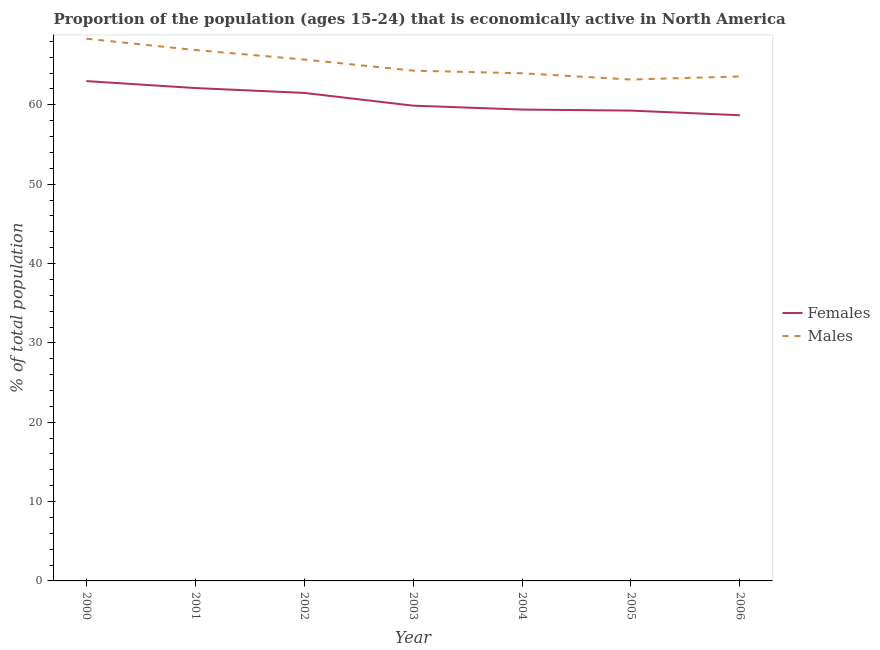How many different coloured lines are there?
Give a very brief answer. 2. What is the percentage of economically active male population in 2004?
Ensure brevity in your answer.  63.98. Across all years, what is the maximum percentage of economically active male population?
Your answer should be compact. 68.33. Across all years, what is the minimum percentage of economically active female population?
Your answer should be compact. 58.69. In which year was the percentage of economically active female population maximum?
Keep it short and to the point. 2000. In which year was the percentage of economically active female population minimum?
Make the answer very short. 2006. What is the total percentage of economically active male population in the graph?
Your answer should be compact. 455.99. What is the difference between the percentage of economically active female population in 2001 and that in 2005?
Keep it short and to the point. 2.84. What is the difference between the percentage of economically active female population in 2004 and the percentage of economically active male population in 2001?
Offer a very short reply. -7.5. What is the average percentage of economically active female population per year?
Offer a very short reply. 60.55. In the year 2005, what is the difference between the percentage of economically active male population and percentage of economically active female population?
Your answer should be compact. 3.92. What is the ratio of the percentage of economically active male population in 2001 to that in 2004?
Give a very brief answer. 1.05. What is the difference between the highest and the second highest percentage of economically active male population?
Your answer should be compact. 1.43. What is the difference between the highest and the lowest percentage of economically active female population?
Keep it short and to the point. 4.3. In how many years, is the percentage of economically active male population greater than the average percentage of economically active male population taken over all years?
Ensure brevity in your answer.  3. Is the percentage of economically active male population strictly less than the percentage of economically active female population over the years?
Offer a very short reply. No. How many lines are there?
Provide a succinct answer. 2. How many years are there in the graph?
Offer a very short reply. 7. What is the difference between two consecutive major ticks on the Y-axis?
Your response must be concise. 10. Where does the legend appear in the graph?
Your answer should be compact. Center right. How many legend labels are there?
Provide a short and direct response. 2. What is the title of the graph?
Your answer should be compact. Proportion of the population (ages 15-24) that is economically active in North America. Does "Tetanus" appear as one of the legend labels in the graph?
Give a very brief answer. No. What is the label or title of the X-axis?
Keep it short and to the point. Year. What is the label or title of the Y-axis?
Your answer should be very brief. % of total population. What is the % of total population of Females in 2000?
Make the answer very short. 62.99. What is the % of total population in Males in 2000?
Keep it short and to the point. 68.33. What is the % of total population in Females in 2001?
Your answer should be compact. 62.11. What is the % of total population of Males in 2001?
Keep it short and to the point. 66.9. What is the % of total population of Females in 2002?
Keep it short and to the point. 61.5. What is the % of total population of Males in 2002?
Your response must be concise. 65.71. What is the % of total population in Females in 2003?
Make the answer very short. 59.9. What is the % of total population in Males in 2003?
Your answer should be very brief. 64.31. What is the % of total population of Females in 2004?
Offer a terse response. 59.4. What is the % of total population of Males in 2004?
Make the answer very short. 63.98. What is the % of total population of Females in 2005?
Offer a terse response. 59.27. What is the % of total population of Males in 2005?
Your response must be concise. 63.19. What is the % of total population in Females in 2006?
Offer a very short reply. 58.69. What is the % of total population in Males in 2006?
Provide a succinct answer. 63.57. Across all years, what is the maximum % of total population of Females?
Give a very brief answer. 62.99. Across all years, what is the maximum % of total population in Males?
Offer a very short reply. 68.33. Across all years, what is the minimum % of total population in Females?
Make the answer very short. 58.69. Across all years, what is the minimum % of total population of Males?
Offer a terse response. 63.19. What is the total % of total population in Females in the graph?
Keep it short and to the point. 423.87. What is the total % of total population in Males in the graph?
Offer a terse response. 455.99. What is the difference between the % of total population of Females in 2000 and that in 2001?
Keep it short and to the point. 0.88. What is the difference between the % of total population of Males in 2000 and that in 2001?
Make the answer very short. 1.43. What is the difference between the % of total population of Females in 2000 and that in 2002?
Your answer should be very brief. 1.49. What is the difference between the % of total population of Males in 2000 and that in 2002?
Keep it short and to the point. 2.63. What is the difference between the % of total population in Females in 2000 and that in 2003?
Provide a short and direct response. 3.1. What is the difference between the % of total population in Males in 2000 and that in 2003?
Your answer should be compact. 4.03. What is the difference between the % of total population of Females in 2000 and that in 2004?
Your answer should be very brief. 3.59. What is the difference between the % of total population in Males in 2000 and that in 2004?
Make the answer very short. 4.36. What is the difference between the % of total population in Females in 2000 and that in 2005?
Your response must be concise. 3.72. What is the difference between the % of total population in Males in 2000 and that in 2005?
Keep it short and to the point. 5.14. What is the difference between the % of total population in Females in 2000 and that in 2006?
Give a very brief answer. 4.3. What is the difference between the % of total population of Males in 2000 and that in 2006?
Make the answer very short. 4.76. What is the difference between the % of total population of Females in 2001 and that in 2002?
Your answer should be very brief. 0.61. What is the difference between the % of total population of Males in 2001 and that in 2002?
Your answer should be compact. 1.2. What is the difference between the % of total population of Females in 2001 and that in 2003?
Your response must be concise. 2.22. What is the difference between the % of total population in Males in 2001 and that in 2003?
Your response must be concise. 2.6. What is the difference between the % of total population of Females in 2001 and that in 2004?
Keep it short and to the point. 2.71. What is the difference between the % of total population in Males in 2001 and that in 2004?
Ensure brevity in your answer.  2.93. What is the difference between the % of total population in Females in 2001 and that in 2005?
Your answer should be compact. 2.84. What is the difference between the % of total population in Males in 2001 and that in 2005?
Give a very brief answer. 3.71. What is the difference between the % of total population in Females in 2001 and that in 2006?
Provide a short and direct response. 3.43. What is the difference between the % of total population in Males in 2001 and that in 2006?
Provide a short and direct response. 3.33. What is the difference between the % of total population in Females in 2002 and that in 2003?
Your response must be concise. 1.61. What is the difference between the % of total population in Males in 2002 and that in 2003?
Keep it short and to the point. 1.4. What is the difference between the % of total population in Females in 2002 and that in 2004?
Give a very brief answer. 2.1. What is the difference between the % of total population in Males in 2002 and that in 2004?
Your answer should be compact. 1.73. What is the difference between the % of total population in Females in 2002 and that in 2005?
Give a very brief answer. 2.23. What is the difference between the % of total population of Males in 2002 and that in 2005?
Make the answer very short. 2.52. What is the difference between the % of total population in Females in 2002 and that in 2006?
Your answer should be very brief. 2.81. What is the difference between the % of total population in Males in 2002 and that in 2006?
Your answer should be very brief. 2.14. What is the difference between the % of total population of Females in 2003 and that in 2004?
Make the answer very short. 0.49. What is the difference between the % of total population in Males in 2003 and that in 2004?
Your answer should be very brief. 0.33. What is the difference between the % of total population in Females in 2003 and that in 2005?
Your answer should be very brief. 0.62. What is the difference between the % of total population in Males in 2003 and that in 2005?
Offer a very short reply. 1.12. What is the difference between the % of total population of Females in 2003 and that in 2006?
Your answer should be compact. 1.21. What is the difference between the % of total population of Males in 2003 and that in 2006?
Your answer should be very brief. 0.73. What is the difference between the % of total population in Females in 2004 and that in 2005?
Ensure brevity in your answer.  0.13. What is the difference between the % of total population of Males in 2004 and that in 2005?
Your answer should be very brief. 0.79. What is the difference between the % of total population of Females in 2004 and that in 2006?
Give a very brief answer. 0.71. What is the difference between the % of total population of Males in 2004 and that in 2006?
Keep it short and to the point. 0.4. What is the difference between the % of total population in Females in 2005 and that in 2006?
Your answer should be compact. 0.58. What is the difference between the % of total population in Males in 2005 and that in 2006?
Your response must be concise. -0.38. What is the difference between the % of total population of Females in 2000 and the % of total population of Males in 2001?
Your response must be concise. -3.91. What is the difference between the % of total population of Females in 2000 and the % of total population of Males in 2002?
Your answer should be very brief. -2.72. What is the difference between the % of total population in Females in 2000 and the % of total population in Males in 2003?
Your answer should be very brief. -1.32. What is the difference between the % of total population in Females in 2000 and the % of total population in Males in 2004?
Provide a succinct answer. -0.99. What is the difference between the % of total population in Females in 2000 and the % of total population in Males in 2005?
Provide a succinct answer. -0.2. What is the difference between the % of total population in Females in 2000 and the % of total population in Males in 2006?
Provide a succinct answer. -0.58. What is the difference between the % of total population of Females in 2001 and the % of total population of Males in 2002?
Your answer should be compact. -3.59. What is the difference between the % of total population in Females in 2001 and the % of total population in Males in 2003?
Offer a terse response. -2.19. What is the difference between the % of total population in Females in 2001 and the % of total population in Males in 2004?
Your response must be concise. -1.86. What is the difference between the % of total population of Females in 2001 and the % of total population of Males in 2005?
Provide a succinct answer. -1.08. What is the difference between the % of total population in Females in 2001 and the % of total population in Males in 2006?
Make the answer very short. -1.46. What is the difference between the % of total population of Females in 2002 and the % of total population of Males in 2003?
Your response must be concise. -2.81. What is the difference between the % of total population in Females in 2002 and the % of total population in Males in 2004?
Your answer should be very brief. -2.48. What is the difference between the % of total population in Females in 2002 and the % of total population in Males in 2005?
Your response must be concise. -1.69. What is the difference between the % of total population in Females in 2002 and the % of total population in Males in 2006?
Your response must be concise. -2.07. What is the difference between the % of total population of Females in 2003 and the % of total population of Males in 2004?
Your response must be concise. -4.08. What is the difference between the % of total population in Females in 2003 and the % of total population in Males in 2005?
Provide a succinct answer. -3.3. What is the difference between the % of total population of Females in 2003 and the % of total population of Males in 2006?
Keep it short and to the point. -3.68. What is the difference between the % of total population of Females in 2004 and the % of total population of Males in 2005?
Ensure brevity in your answer.  -3.79. What is the difference between the % of total population of Females in 2004 and the % of total population of Males in 2006?
Ensure brevity in your answer.  -4.17. What is the difference between the % of total population in Females in 2005 and the % of total population in Males in 2006?
Provide a succinct answer. -4.3. What is the average % of total population in Females per year?
Your response must be concise. 60.55. What is the average % of total population in Males per year?
Provide a succinct answer. 65.14. In the year 2000, what is the difference between the % of total population of Females and % of total population of Males?
Your response must be concise. -5.34. In the year 2001, what is the difference between the % of total population in Females and % of total population in Males?
Make the answer very short. -4.79. In the year 2002, what is the difference between the % of total population in Females and % of total population in Males?
Keep it short and to the point. -4.21. In the year 2003, what is the difference between the % of total population in Females and % of total population in Males?
Give a very brief answer. -4.41. In the year 2004, what is the difference between the % of total population in Females and % of total population in Males?
Provide a short and direct response. -4.57. In the year 2005, what is the difference between the % of total population of Females and % of total population of Males?
Your response must be concise. -3.92. In the year 2006, what is the difference between the % of total population in Females and % of total population in Males?
Make the answer very short. -4.88. What is the ratio of the % of total population in Females in 2000 to that in 2001?
Give a very brief answer. 1.01. What is the ratio of the % of total population in Males in 2000 to that in 2001?
Ensure brevity in your answer.  1.02. What is the ratio of the % of total population of Females in 2000 to that in 2002?
Make the answer very short. 1.02. What is the ratio of the % of total population in Males in 2000 to that in 2002?
Offer a very short reply. 1.04. What is the ratio of the % of total population in Females in 2000 to that in 2003?
Make the answer very short. 1.05. What is the ratio of the % of total population of Males in 2000 to that in 2003?
Ensure brevity in your answer.  1.06. What is the ratio of the % of total population of Females in 2000 to that in 2004?
Keep it short and to the point. 1.06. What is the ratio of the % of total population of Males in 2000 to that in 2004?
Provide a short and direct response. 1.07. What is the ratio of the % of total population of Females in 2000 to that in 2005?
Give a very brief answer. 1.06. What is the ratio of the % of total population of Males in 2000 to that in 2005?
Keep it short and to the point. 1.08. What is the ratio of the % of total population of Females in 2000 to that in 2006?
Make the answer very short. 1.07. What is the ratio of the % of total population of Males in 2000 to that in 2006?
Your answer should be compact. 1.07. What is the ratio of the % of total population in Males in 2001 to that in 2002?
Your response must be concise. 1.02. What is the ratio of the % of total population in Females in 2001 to that in 2003?
Provide a succinct answer. 1.04. What is the ratio of the % of total population of Males in 2001 to that in 2003?
Provide a succinct answer. 1.04. What is the ratio of the % of total population in Females in 2001 to that in 2004?
Keep it short and to the point. 1.05. What is the ratio of the % of total population in Males in 2001 to that in 2004?
Make the answer very short. 1.05. What is the ratio of the % of total population of Females in 2001 to that in 2005?
Offer a very short reply. 1.05. What is the ratio of the % of total population of Males in 2001 to that in 2005?
Your answer should be compact. 1.06. What is the ratio of the % of total population of Females in 2001 to that in 2006?
Provide a succinct answer. 1.06. What is the ratio of the % of total population of Males in 2001 to that in 2006?
Your answer should be very brief. 1.05. What is the ratio of the % of total population in Females in 2002 to that in 2003?
Your response must be concise. 1.03. What is the ratio of the % of total population of Males in 2002 to that in 2003?
Your answer should be compact. 1.02. What is the ratio of the % of total population in Females in 2002 to that in 2004?
Ensure brevity in your answer.  1.04. What is the ratio of the % of total population in Males in 2002 to that in 2004?
Your answer should be very brief. 1.03. What is the ratio of the % of total population in Females in 2002 to that in 2005?
Your answer should be compact. 1.04. What is the ratio of the % of total population of Males in 2002 to that in 2005?
Give a very brief answer. 1.04. What is the ratio of the % of total population in Females in 2002 to that in 2006?
Provide a short and direct response. 1.05. What is the ratio of the % of total population of Males in 2002 to that in 2006?
Offer a terse response. 1.03. What is the ratio of the % of total population of Females in 2003 to that in 2004?
Your response must be concise. 1.01. What is the ratio of the % of total population in Males in 2003 to that in 2004?
Provide a short and direct response. 1.01. What is the ratio of the % of total population of Females in 2003 to that in 2005?
Make the answer very short. 1.01. What is the ratio of the % of total population of Males in 2003 to that in 2005?
Keep it short and to the point. 1.02. What is the ratio of the % of total population in Females in 2003 to that in 2006?
Provide a short and direct response. 1.02. What is the ratio of the % of total population in Males in 2003 to that in 2006?
Ensure brevity in your answer.  1.01. What is the ratio of the % of total population in Females in 2004 to that in 2005?
Offer a terse response. 1. What is the ratio of the % of total population of Males in 2004 to that in 2005?
Your answer should be compact. 1.01. What is the ratio of the % of total population of Females in 2004 to that in 2006?
Your response must be concise. 1.01. What is the ratio of the % of total population in Males in 2004 to that in 2006?
Ensure brevity in your answer.  1.01. What is the ratio of the % of total population in Females in 2005 to that in 2006?
Ensure brevity in your answer.  1.01. What is the ratio of the % of total population in Males in 2005 to that in 2006?
Provide a succinct answer. 0.99. What is the difference between the highest and the second highest % of total population in Females?
Ensure brevity in your answer.  0.88. What is the difference between the highest and the second highest % of total population of Males?
Offer a very short reply. 1.43. What is the difference between the highest and the lowest % of total population of Females?
Provide a succinct answer. 4.3. What is the difference between the highest and the lowest % of total population of Males?
Keep it short and to the point. 5.14. 